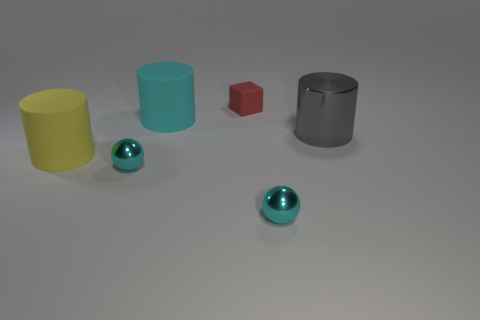Add 4 small red matte blocks. How many objects exist? 10 Subtract all gray metallic cylinders. How many cylinders are left? 2 Subtract all gray cylinders. How many cylinders are left? 2 Subtract all spheres. How many objects are left? 4 Subtract 1 spheres. How many spheres are left? 1 Subtract 0 cyan blocks. How many objects are left? 6 Subtract all purple cylinders. Subtract all gray cubes. How many cylinders are left? 3 Subtract all gray rubber cylinders. Subtract all tiny objects. How many objects are left? 3 Add 6 large yellow things. How many large yellow things are left? 7 Add 2 tiny red objects. How many tiny red objects exist? 3 